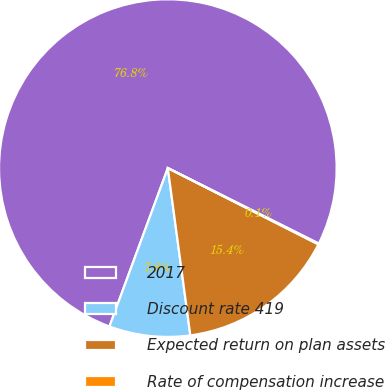<chart> <loc_0><loc_0><loc_500><loc_500><pie_chart><fcel>2017<fcel>Discount rate 419<fcel>Expected return on plan assets<fcel>Rate of compensation increase<nl><fcel>76.76%<fcel>7.75%<fcel>15.41%<fcel>0.08%<nl></chart> 